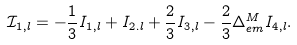<formula> <loc_0><loc_0><loc_500><loc_500>\mathcal { I } _ { 1 , l } = - \frac { 1 } { 3 } I _ { 1 , l } + I _ { 2 . l } + \frac { 2 } { 3 } I _ { 3 , l } - \frac { 2 } { 3 } \Delta ^ { M } _ { e m } I _ { 4 , l } .</formula> 